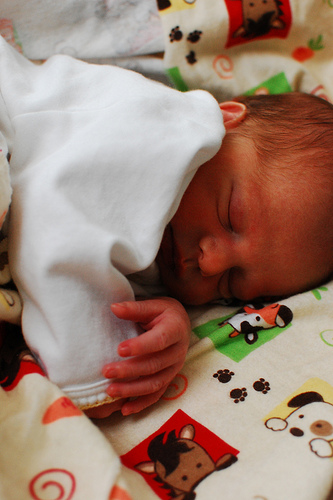<image>
Is there a baby under the shirt? Yes. The baby is positioned underneath the shirt, with the shirt above it in the vertical space. Is there a baby behind the bed? No. The baby is not behind the bed. From this viewpoint, the baby appears to be positioned elsewhere in the scene. 